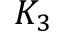<formula> <loc_0><loc_0><loc_500><loc_500>K _ { 3 }</formula> 